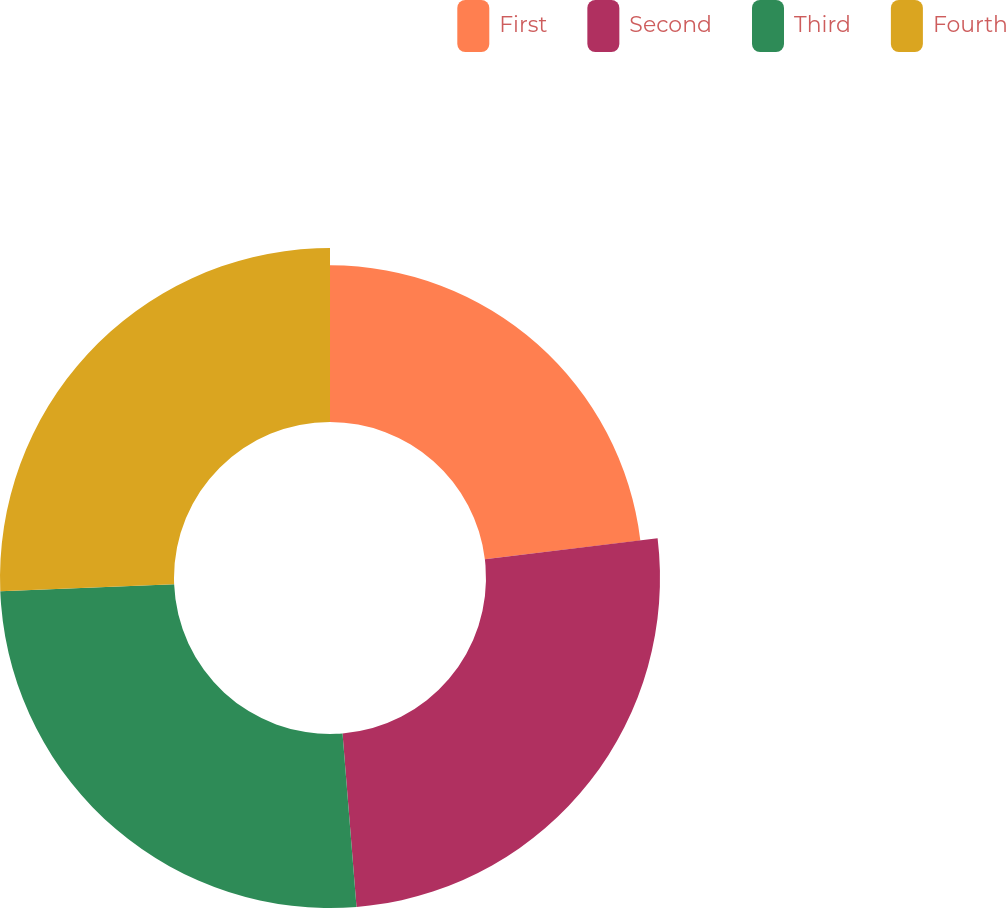<chart> <loc_0><loc_0><loc_500><loc_500><pie_chart><fcel>First<fcel>Second<fcel>Third<fcel>Fourth<nl><fcel>23.08%<fcel>25.64%<fcel>25.64%<fcel>25.64%<nl></chart> 